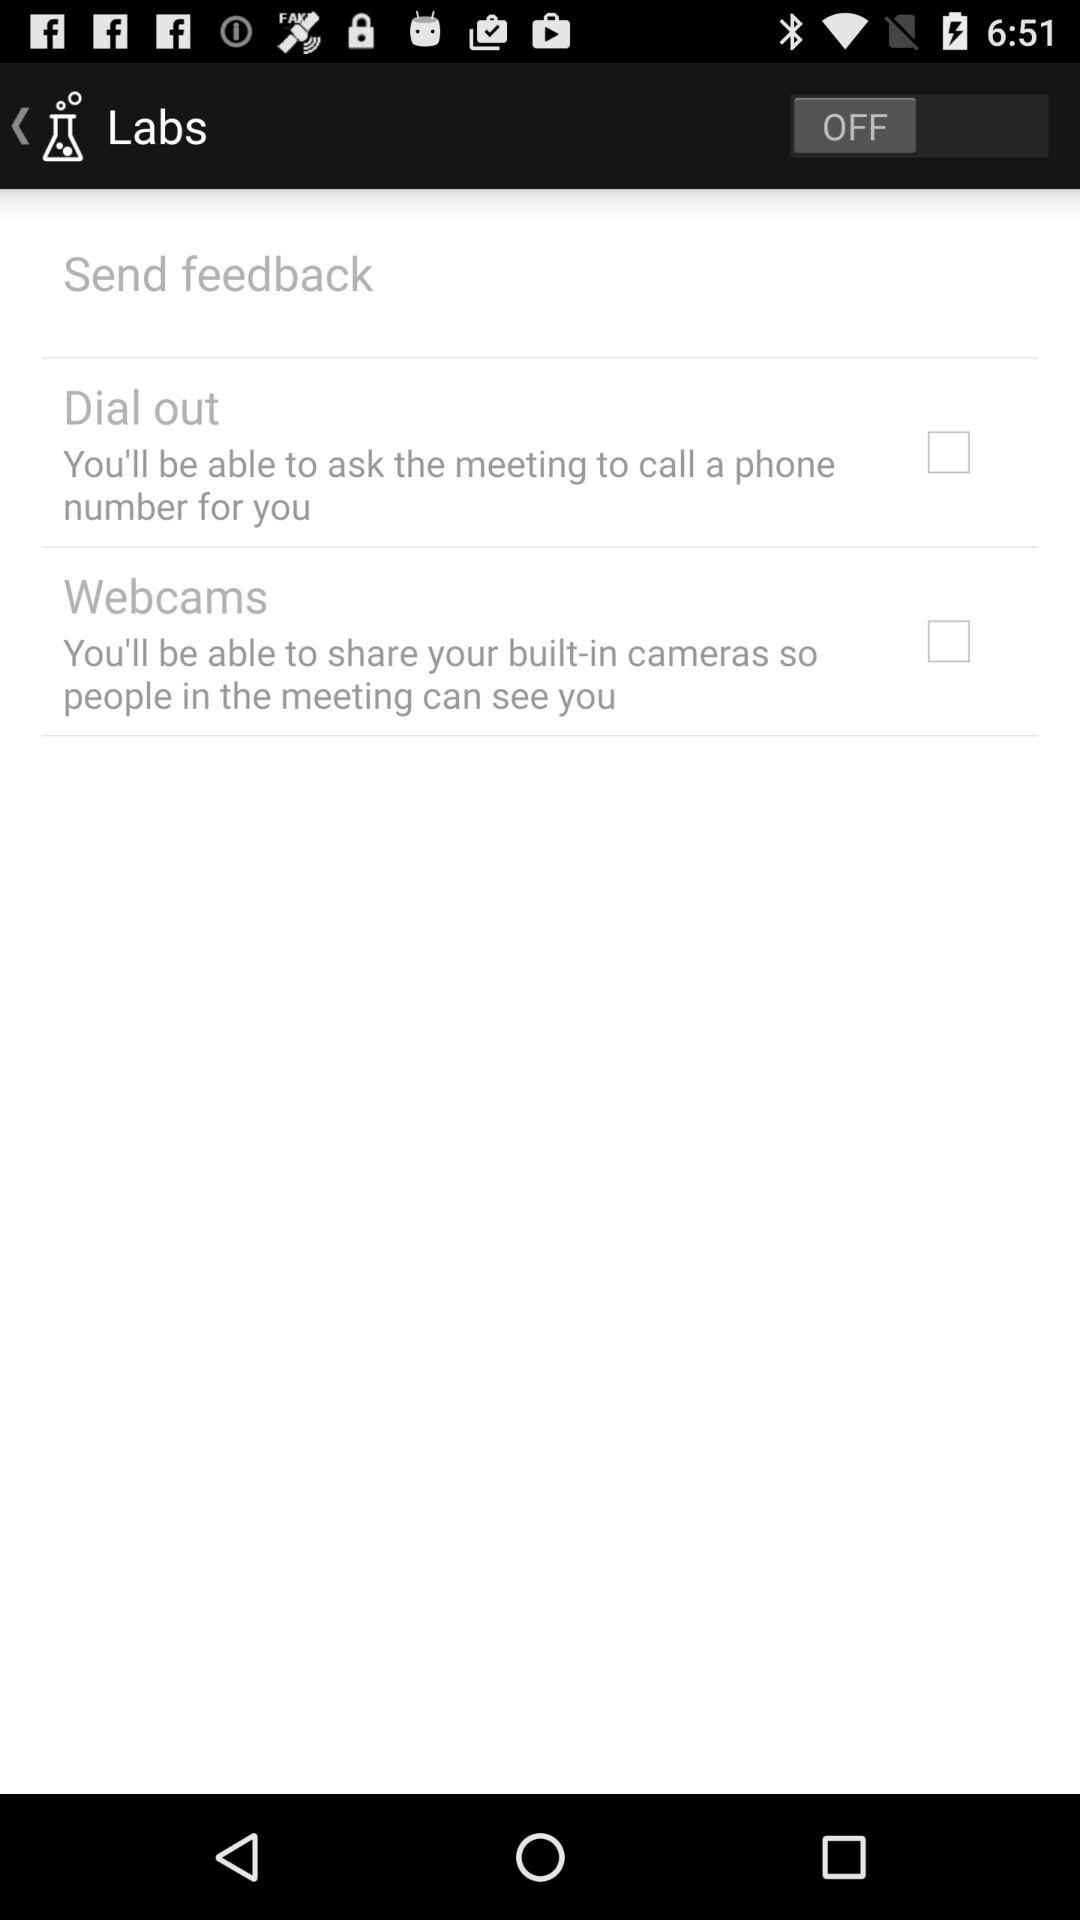What is the name of the application?
When the provided information is insufficient, respond with <no answer>. <no answer> 